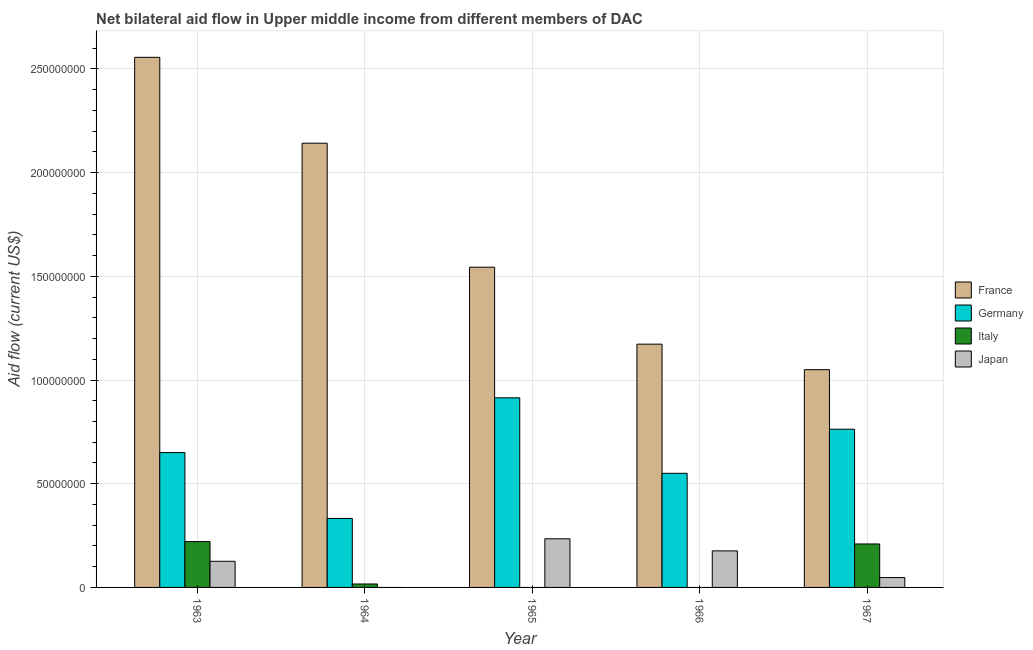How many groups of bars are there?
Your response must be concise. 5. Are the number of bars on each tick of the X-axis equal?
Your response must be concise. No. How many bars are there on the 1st tick from the left?
Offer a terse response. 4. What is the label of the 5th group of bars from the left?
Give a very brief answer. 1967. In how many cases, is the number of bars for a given year not equal to the number of legend labels?
Ensure brevity in your answer.  3. What is the amount of aid given by italy in 1963?
Provide a short and direct response. 2.21e+07. Across all years, what is the maximum amount of aid given by italy?
Offer a very short reply. 2.21e+07. Across all years, what is the minimum amount of aid given by italy?
Offer a very short reply. 0. In which year was the amount of aid given by germany maximum?
Make the answer very short. 1965. What is the total amount of aid given by italy in the graph?
Offer a very short reply. 4.47e+07. What is the difference between the amount of aid given by japan in 1965 and that in 1966?
Your answer should be compact. 5.82e+06. What is the difference between the amount of aid given by germany in 1965 and the amount of aid given by japan in 1967?
Make the answer very short. 1.51e+07. What is the average amount of aid given by italy per year?
Provide a succinct answer. 8.94e+06. In the year 1963, what is the difference between the amount of aid given by germany and amount of aid given by france?
Offer a very short reply. 0. In how many years, is the amount of aid given by france greater than 80000000 US$?
Offer a very short reply. 5. What is the ratio of the amount of aid given by france in 1963 to that in 1966?
Your answer should be compact. 2.18. Is the difference between the amount of aid given by italy in 1963 and 1964 greater than the difference between the amount of aid given by germany in 1963 and 1964?
Give a very brief answer. No. What is the difference between the highest and the second highest amount of aid given by italy?
Your answer should be very brief. 1.14e+06. What is the difference between the highest and the lowest amount of aid given by france?
Keep it short and to the point. 1.51e+08. Is it the case that in every year, the sum of the amount of aid given by france and amount of aid given by germany is greater than the amount of aid given by italy?
Provide a short and direct response. Yes. Does the graph contain grids?
Keep it short and to the point. Yes. What is the title of the graph?
Provide a succinct answer. Net bilateral aid flow in Upper middle income from different members of DAC. What is the Aid flow (current US$) in France in 1963?
Make the answer very short. 2.56e+08. What is the Aid flow (current US$) in Germany in 1963?
Keep it short and to the point. 6.50e+07. What is the Aid flow (current US$) of Italy in 1963?
Your answer should be compact. 2.21e+07. What is the Aid flow (current US$) of Japan in 1963?
Provide a short and direct response. 1.26e+07. What is the Aid flow (current US$) in France in 1964?
Ensure brevity in your answer.  2.14e+08. What is the Aid flow (current US$) in Germany in 1964?
Offer a terse response. 3.32e+07. What is the Aid flow (current US$) in Italy in 1964?
Your response must be concise. 1.66e+06. What is the Aid flow (current US$) of Japan in 1964?
Offer a very short reply. 0. What is the Aid flow (current US$) in France in 1965?
Offer a very short reply. 1.54e+08. What is the Aid flow (current US$) of Germany in 1965?
Provide a succinct answer. 9.14e+07. What is the Aid flow (current US$) of Italy in 1965?
Keep it short and to the point. 0. What is the Aid flow (current US$) of Japan in 1965?
Make the answer very short. 2.34e+07. What is the Aid flow (current US$) of France in 1966?
Provide a short and direct response. 1.17e+08. What is the Aid flow (current US$) of Germany in 1966?
Make the answer very short. 5.50e+07. What is the Aid flow (current US$) in Japan in 1966?
Your answer should be compact. 1.76e+07. What is the Aid flow (current US$) in France in 1967?
Offer a very short reply. 1.05e+08. What is the Aid flow (current US$) in Germany in 1967?
Provide a succinct answer. 7.63e+07. What is the Aid flow (current US$) in Italy in 1967?
Provide a short and direct response. 2.10e+07. What is the Aid flow (current US$) of Japan in 1967?
Ensure brevity in your answer.  4.77e+06. Across all years, what is the maximum Aid flow (current US$) in France?
Your response must be concise. 2.56e+08. Across all years, what is the maximum Aid flow (current US$) of Germany?
Offer a terse response. 9.14e+07. Across all years, what is the maximum Aid flow (current US$) of Italy?
Ensure brevity in your answer.  2.21e+07. Across all years, what is the maximum Aid flow (current US$) in Japan?
Offer a very short reply. 2.34e+07. Across all years, what is the minimum Aid flow (current US$) in France?
Your response must be concise. 1.05e+08. Across all years, what is the minimum Aid flow (current US$) in Germany?
Provide a short and direct response. 3.32e+07. Across all years, what is the minimum Aid flow (current US$) in Italy?
Your response must be concise. 0. Across all years, what is the minimum Aid flow (current US$) in Japan?
Give a very brief answer. 0. What is the total Aid flow (current US$) in France in the graph?
Your answer should be very brief. 8.46e+08. What is the total Aid flow (current US$) in Germany in the graph?
Offer a very short reply. 3.21e+08. What is the total Aid flow (current US$) in Italy in the graph?
Your answer should be compact. 4.47e+07. What is the total Aid flow (current US$) of Japan in the graph?
Offer a terse response. 5.84e+07. What is the difference between the Aid flow (current US$) of France in 1963 and that in 1964?
Provide a succinct answer. 4.14e+07. What is the difference between the Aid flow (current US$) in Germany in 1963 and that in 1964?
Give a very brief answer. 3.18e+07. What is the difference between the Aid flow (current US$) in Italy in 1963 and that in 1964?
Make the answer very short. 2.04e+07. What is the difference between the Aid flow (current US$) in France in 1963 and that in 1965?
Provide a short and direct response. 1.01e+08. What is the difference between the Aid flow (current US$) in Germany in 1963 and that in 1965?
Provide a short and direct response. -2.64e+07. What is the difference between the Aid flow (current US$) in Japan in 1963 and that in 1965?
Your answer should be very brief. -1.08e+07. What is the difference between the Aid flow (current US$) in France in 1963 and that in 1966?
Ensure brevity in your answer.  1.38e+08. What is the difference between the Aid flow (current US$) in Germany in 1963 and that in 1966?
Offer a terse response. 9.97e+06. What is the difference between the Aid flow (current US$) in Japan in 1963 and that in 1966?
Your response must be concise. -5.03e+06. What is the difference between the Aid flow (current US$) in France in 1963 and that in 1967?
Provide a succinct answer. 1.51e+08. What is the difference between the Aid flow (current US$) of Germany in 1963 and that in 1967?
Your response must be concise. -1.13e+07. What is the difference between the Aid flow (current US$) in Italy in 1963 and that in 1967?
Keep it short and to the point. 1.14e+06. What is the difference between the Aid flow (current US$) of Japan in 1963 and that in 1967?
Offer a terse response. 7.83e+06. What is the difference between the Aid flow (current US$) of France in 1964 and that in 1965?
Your answer should be very brief. 5.98e+07. What is the difference between the Aid flow (current US$) in Germany in 1964 and that in 1965?
Provide a succinct answer. -5.82e+07. What is the difference between the Aid flow (current US$) in France in 1964 and that in 1966?
Make the answer very short. 9.69e+07. What is the difference between the Aid flow (current US$) in Germany in 1964 and that in 1966?
Offer a terse response. -2.18e+07. What is the difference between the Aid flow (current US$) in France in 1964 and that in 1967?
Provide a short and direct response. 1.09e+08. What is the difference between the Aid flow (current US$) of Germany in 1964 and that in 1967?
Provide a succinct answer. -4.30e+07. What is the difference between the Aid flow (current US$) of Italy in 1964 and that in 1967?
Provide a succinct answer. -1.93e+07. What is the difference between the Aid flow (current US$) of France in 1965 and that in 1966?
Make the answer very short. 3.71e+07. What is the difference between the Aid flow (current US$) in Germany in 1965 and that in 1966?
Provide a succinct answer. 3.64e+07. What is the difference between the Aid flow (current US$) in Japan in 1965 and that in 1966?
Ensure brevity in your answer.  5.82e+06. What is the difference between the Aid flow (current US$) of France in 1965 and that in 1967?
Your answer should be very brief. 4.94e+07. What is the difference between the Aid flow (current US$) in Germany in 1965 and that in 1967?
Provide a short and direct response. 1.51e+07. What is the difference between the Aid flow (current US$) of Japan in 1965 and that in 1967?
Give a very brief answer. 1.87e+07. What is the difference between the Aid flow (current US$) of France in 1966 and that in 1967?
Keep it short and to the point. 1.23e+07. What is the difference between the Aid flow (current US$) of Germany in 1966 and that in 1967?
Give a very brief answer. -2.13e+07. What is the difference between the Aid flow (current US$) in Japan in 1966 and that in 1967?
Offer a terse response. 1.29e+07. What is the difference between the Aid flow (current US$) in France in 1963 and the Aid flow (current US$) in Germany in 1964?
Offer a very short reply. 2.22e+08. What is the difference between the Aid flow (current US$) in France in 1963 and the Aid flow (current US$) in Italy in 1964?
Your answer should be very brief. 2.54e+08. What is the difference between the Aid flow (current US$) in Germany in 1963 and the Aid flow (current US$) in Italy in 1964?
Provide a succinct answer. 6.33e+07. What is the difference between the Aid flow (current US$) in France in 1963 and the Aid flow (current US$) in Germany in 1965?
Make the answer very short. 1.64e+08. What is the difference between the Aid flow (current US$) in France in 1963 and the Aid flow (current US$) in Japan in 1965?
Your answer should be very brief. 2.32e+08. What is the difference between the Aid flow (current US$) in Germany in 1963 and the Aid flow (current US$) in Japan in 1965?
Offer a very short reply. 4.16e+07. What is the difference between the Aid flow (current US$) in Italy in 1963 and the Aid flow (current US$) in Japan in 1965?
Give a very brief answer. -1.35e+06. What is the difference between the Aid flow (current US$) of France in 1963 and the Aid flow (current US$) of Germany in 1966?
Offer a terse response. 2.01e+08. What is the difference between the Aid flow (current US$) of France in 1963 and the Aid flow (current US$) of Japan in 1966?
Make the answer very short. 2.38e+08. What is the difference between the Aid flow (current US$) in Germany in 1963 and the Aid flow (current US$) in Japan in 1966?
Ensure brevity in your answer.  4.74e+07. What is the difference between the Aid flow (current US$) in Italy in 1963 and the Aid flow (current US$) in Japan in 1966?
Your response must be concise. 4.47e+06. What is the difference between the Aid flow (current US$) in France in 1963 and the Aid flow (current US$) in Germany in 1967?
Provide a short and direct response. 1.79e+08. What is the difference between the Aid flow (current US$) in France in 1963 and the Aid flow (current US$) in Italy in 1967?
Offer a terse response. 2.35e+08. What is the difference between the Aid flow (current US$) of France in 1963 and the Aid flow (current US$) of Japan in 1967?
Your response must be concise. 2.51e+08. What is the difference between the Aid flow (current US$) in Germany in 1963 and the Aid flow (current US$) in Italy in 1967?
Give a very brief answer. 4.40e+07. What is the difference between the Aid flow (current US$) of Germany in 1963 and the Aid flow (current US$) of Japan in 1967?
Your answer should be compact. 6.02e+07. What is the difference between the Aid flow (current US$) in Italy in 1963 and the Aid flow (current US$) in Japan in 1967?
Your answer should be compact. 1.73e+07. What is the difference between the Aid flow (current US$) in France in 1964 and the Aid flow (current US$) in Germany in 1965?
Offer a terse response. 1.23e+08. What is the difference between the Aid flow (current US$) of France in 1964 and the Aid flow (current US$) of Japan in 1965?
Keep it short and to the point. 1.91e+08. What is the difference between the Aid flow (current US$) in Germany in 1964 and the Aid flow (current US$) in Japan in 1965?
Make the answer very short. 9.80e+06. What is the difference between the Aid flow (current US$) of Italy in 1964 and the Aid flow (current US$) of Japan in 1965?
Offer a very short reply. -2.18e+07. What is the difference between the Aid flow (current US$) in France in 1964 and the Aid flow (current US$) in Germany in 1966?
Give a very brief answer. 1.59e+08. What is the difference between the Aid flow (current US$) of France in 1964 and the Aid flow (current US$) of Japan in 1966?
Provide a succinct answer. 1.97e+08. What is the difference between the Aid flow (current US$) of Germany in 1964 and the Aid flow (current US$) of Japan in 1966?
Give a very brief answer. 1.56e+07. What is the difference between the Aid flow (current US$) of Italy in 1964 and the Aid flow (current US$) of Japan in 1966?
Your answer should be very brief. -1.60e+07. What is the difference between the Aid flow (current US$) of France in 1964 and the Aid flow (current US$) of Germany in 1967?
Make the answer very short. 1.38e+08. What is the difference between the Aid flow (current US$) of France in 1964 and the Aid flow (current US$) of Italy in 1967?
Offer a terse response. 1.93e+08. What is the difference between the Aid flow (current US$) of France in 1964 and the Aid flow (current US$) of Japan in 1967?
Your answer should be compact. 2.09e+08. What is the difference between the Aid flow (current US$) of Germany in 1964 and the Aid flow (current US$) of Italy in 1967?
Your answer should be compact. 1.23e+07. What is the difference between the Aid flow (current US$) in Germany in 1964 and the Aid flow (current US$) in Japan in 1967?
Offer a terse response. 2.85e+07. What is the difference between the Aid flow (current US$) of Italy in 1964 and the Aid flow (current US$) of Japan in 1967?
Make the answer very short. -3.11e+06. What is the difference between the Aid flow (current US$) of France in 1965 and the Aid flow (current US$) of Germany in 1966?
Provide a succinct answer. 9.94e+07. What is the difference between the Aid flow (current US$) of France in 1965 and the Aid flow (current US$) of Japan in 1966?
Give a very brief answer. 1.37e+08. What is the difference between the Aid flow (current US$) of Germany in 1965 and the Aid flow (current US$) of Japan in 1966?
Offer a terse response. 7.38e+07. What is the difference between the Aid flow (current US$) of France in 1965 and the Aid flow (current US$) of Germany in 1967?
Ensure brevity in your answer.  7.81e+07. What is the difference between the Aid flow (current US$) of France in 1965 and the Aid flow (current US$) of Italy in 1967?
Your answer should be compact. 1.33e+08. What is the difference between the Aid flow (current US$) of France in 1965 and the Aid flow (current US$) of Japan in 1967?
Provide a succinct answer. 1.50e+08. What is the difference between the Aid flow (current US$) of Germany in 1965 and the Aid flow (current US$) of Italy in 1967?
Your response must be concise. 7.05e+07. What is the difference between the Aid flow (current US$) of Germany in 1965 and the Aid flow (current US$) of Japan in 1967?
Your response must be concise. 8.66e+07. What is the difference between the Aid flow (current US$) of France in 1966 and the Aid flow (current US$) of Germany in 1967?
Keep it short and to the point. 4.10e+07. What is the difference between the Aid flow (current US$) in France in 1966 and the Aid flow (current US$) in Italy in 1967?
Offer a terse response. 9.63e+07. What is the difference between the Aid flow (current US$) of France in 1966 and the Aid flow (current US$) of Japan in 1967?
Ensure brevity in your answer.  1.13e+08. What is the difference between the Aid flow (current US$) in Germany in 1966 and the Aid flow (current US$) in Italy in 1967?
Offer a very short reply. 3.41e+07. What is the difference between the Aid flow (current US$) in Germany in 1966 and the Aid flow (current US$) in Japan in 1967?
Your answer should be compact. 5.03e+07. What is the average Aid flow (current US$) of France per year?
Your response must be concise. 1.69e+08. What is the average Aid flow (current US$) in Germany per year?
Give a very brief answer. 6.42e+07. What is the average Aid flow (current US$) of Italy per year?
Provide a succinct answer. 8.94e+06. What is the average Aid flow (current US$) in Japan per year?
Offer a very short reply. 1.17e+07. In the year 1963, what is the difference between the Aid flow (current US$) of France and Aid flow (current US$) of Germany?
Offer a terse response. 1.91e+08. In the year 1963, what is the difference between the Aid flow (current US$) in France and Aid flow (current US$) in Italy?
Offer a very short reply. 2.34e+08. In the year 1963, what is the difference between the Aid flow (current US$) in France and Aid flow (current US$) in Japan?
Your answer should be very brief. 2.43e+08. In the year 1963, what is the difference between the Aid flow (current US$) of Germany and Aid flow (current US$) of Italy?
Ensure brevity in your answer.  4.29e+07. In the year 1963, what is the difference between the Aid flow (current US$) in Germany and Aid flow (current US$) in Japan?
Your answer should be very brief. 5.24e+07. In the year 1963, what is the difference between the Aid flow (current US$) of Italy and Aid flow (current US$) of Japan?
Give a very brief answer. 9.50e+06. In the year 1964, what is the difference between the Aid flow (current US$) in France and Aid flow (current US$) in Germany?
Your response must be concise. 1.81e+08. In the year 1964, what is the difference between the Aid flow (current US$) in France and Aid flow (current US$) in Italy?
Give a very brief answer. 2.13e+08. In the year 1964, what is the difference between the Aid flow (current US$) in Germany and Aid flow (current US$) in Italy?
Ensure brevity in your answer.  3.16e+07. In the year 1965, what is the difference between the Aid flow (current US$) in France and Aid flow (current US$) in Germany?
Offer a very short reply. 6.30e+07. In the year 1965, what is the difference between the Aid flow (current US$) of France and Aid flow (current US$) of Japan?
Provide a succinct answer. 1.31e+08. In the year 1965, what is the difference between the Aid flow (current US$) of Germany and Aid flow (current US$) of Japan?
Your response must be concise. 6.80e+07. In the year 1966, what is the difference between the Aid flow (current US$) in France and Aid flow (current US$) in Germany?
Give a very brief answer. 6.23e+07. In the year 1966, what is the difference between the Aid flow (current US$) in France and Aid flow (current US$) in Japan?
Make the answer very short. 9.97e+07. In the year 1966, what is the difference between the Aid flow (current US$) in Germany and Aid flow (current US$) in Japan?
Make the answer very short. 3.74e+07. In the year 1967, what is the difference between the Aid flow (current US$) in France and Aid flow (current US$) in Germany?
Make the answer very short. 2.87e+07. In the year 1967, what is the difference between the Aid flow (current US$) in France and Aid flow (current US$) in Italy?
Keep it short and to the point. 8.40e+07. In the year 1967, what is the difference between the Aid flow (current US$) of France and Aid flow (current US$) of Japan?
Ensure brevity in your answer.  1.00e+08. In the year 1967, what is the difference between the Aid flow (current US$) in Germany and Aid flow (current US$) in Italy?
Ensure brevity in your answer.  5.53e+07. In the year 1967, what is the difference between the Aid flow (current US$) in Germany and Aid flow (current US$) in Japan?
Provide a short and direct response. 7.15e+07. In the year 1967, what is the difference between the Aid flow (current US$) in Italy and Aid flow (current US$) in Japan?
Provide a short and direct response. 1.62e+07. What is the ratio of the Aid flow (current US$) of France in 1963 to that in 1964?
Ensure brevity in your answer.  1.19. What is the ratio of the Aid flow (current US$) of Germany in 1963 to that in 1964?
Provide a succinct answer. 1.95. What is the ratio of the Aid flow (current US$) of Italy in 1963 to that in 1964?
Give a very brief answer. 13.31. What is the ratio of the Aid flow (current US$) in France in 1963 to that in 1965?
Make the answer very short. 1.66. What is the ratio of the Aid flow (current US$) of Germany in 1963 to that in 1965?
Your response must be concise. 0.71. What is the ratio of the Aid flow (current US$) of Japan in 1963 to that in 1965?
Ensure brevity in your answer.  0.54. What is the ratio of the Aid flow (current US$) of France in 1963 to that in 1966?
Provide a succinct answer. 2.18. What is the ratio of the Aid flow (current US$) of Germany in 1963 to that in 1966?
Your answer should be compact. 1.18. What is the ratio of the Aid flow (current US$) in Japan in 1963 to that in 1966?
Give a very brief answer. 0.71. What is the ratio of the Aid flow (current US$) of France in 1963 to that in 1967?
Offer a terse response. 2.43. What is the ratio of the Aid flow (current US$) in Germany in 1963 to that in 1967?
Provide a short and direct response. 0.85. What is the ratio of the Aid flow (current US$) of Italy in 1963 to that in 1967?
Ensure brevity in your answer.  1.05. What is the ratio of the Aid flow (current US$) in Japan in 1963 to that in 1967?
Offer a very short reply. 2.64. What is the ratio of the Aid flow (current US$) of France in 1964 to that in 1965?
Ensure brevity in your answer.  1.39. What is the ratio of the Aid flow (current US$) of Germany in 1964 to that in 1965?
Provide a short and direct response. 0.36. What is the ratio of the Aid flow (current US$) in France in 1964 to that in 1966?
Make the answer very short. 1.83. What is the ratio of the Aid flow (current US$) of Germany in 1964 to that in 1966?
Your answer should be very brief. 0.6. What is the ratio of the Aid flow (current US$) of France in 1964 to that in 1967?
Your response must be concise. 2.04. What is the ratio of the Aid flow (current US$) of Germany in 1964 to that in 1967?
Give a very brief answer. 0.44. What is the ratio of the Aid flow (current US$) in Italy in 1964 to that in 1967?
Ensure brevity in your answer.  0.08. What is the ratio of the Aid flow (current US$) of France in 1965 to that in 1966?
Your answer should be very brief. 1.32. What is the ratio of the Aid flow (current US$) of Germany in 1965 to that in 1966?
Provide a short and direct response. 1.66. What is the ratio of the Aid flow (current US$) of Japan in 1965 to that in 1966?
Your response must be concise. 1.33. What is the ratio of the Aid flow (current US$) of France in 1965 to that in 1967?
Your response must be concise. 1.47. What is the ratio of the Aid flow (current US$) of Germany in 1965 to that in 1967?
Provide a succinct answer. 1.2. What is the ratio of the Aid flow (current US$) in Japan in 1965 to that in 1967?
Ensure brevity in your answer.  4.92. What is the ratio of the Aid flow (current US$) of France in 1966 to that in 1967?
Keep it short and to the point. 1.12. What is the ratio of the Aid flow (current US$) of Germany in 1966 to that in 1967?
Offer a terse response. 0.72. What is the ratio of the Aid flow (current US$) of Japan in 1966 to that in 1967?
Make the answer very short. 3.7. What is the difference between the highest and the second highest Aid flow (current US$) in France?
Offer a very short reply. 4.14e+07. What is the difference between the highest and the second highest Aid flow (current US$) in Germany?
Provide a succinct answer. 1.51e+07. What is the difference between the highest and the second highest Aid flow (current US$) of Italy?
Offer a very short reply. 1.14e+06. What is the difference between the highest and the second highest Aid flow (current US$) of Japan?
Ensure brevity in your answer.  5.82e+06. What is the difference between the highest and the lowest Aid flow (current US$) in France?
Your answer should be compact. 1.51e+08. What is the difference between the highest and the lowest Aid flow (current US$) in Germany?
Offer a terse response. 5.82e+07. What is the difference between the highest and the lowest Aid flow (current US$) of Italy?
Keep it short and to the point. 2.21e+07. What is the difference between the highest and the lowest Aid flow (current US$) of Japan?
Offer a terse response. 2.34e+07. 